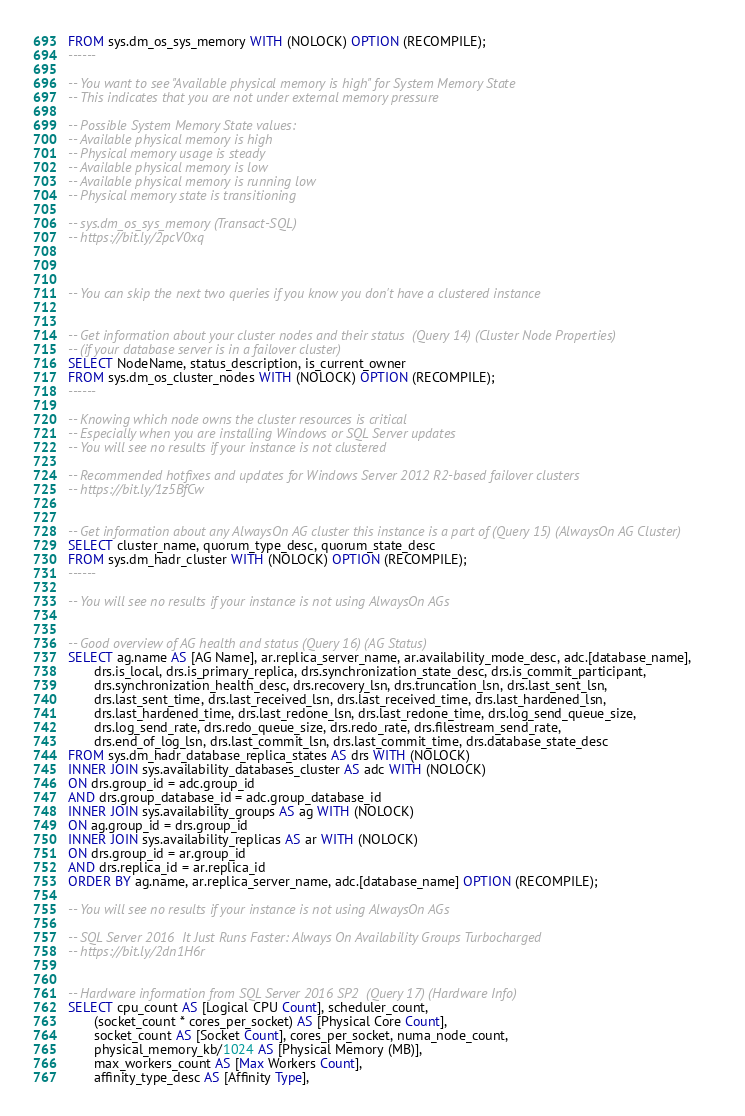<code> <loc_0><loc_0><loc_500><loc_500><_SQL_>FROM sys.dm_os_sys_memory WITH (NOLOCK) OPTION (RECOMPILE);
------

-- You want to see "Available physical memory is high" for System Memory State
-- This indicates that you are not under external memory pressure

-- Possible System Memory State values:
-- Available physical memory is high
-- Physical memory usage is steady
-- Available physical memory is low
-- Available physical memory is running low
-- Physical memory state is transitioning

-- sys.dm_os_sys_memory (Transact-SQL)
-- https://bit.ly/2pcV0xq



-- You can skip the next two queries if you know you don't have a clustered instance


-- Get information about your cluster nodes and their status  (Query 14) (Cluster Node Properties)
-- (if your database server is in a failover cluster)
SELECT NodeName, status_description, is_current_owner
FROM sys.dm_os_cluster_nodes WITH (NOLOCK) OPTION (RECOMPILE);
------

-- Knowing which node owns the cluster resources is critical
-- Especially when you are installing Windows or SQL Server updates
-- You will see no results if your instance is not clustered

-- Recommended hotfixes and updates for Windows Server 2012 R2-based failover clusters
-- https://bit.ly/1z5BfCw


-- Get information about any AlwaysOn AG cluster this instance is a part of (Query 15) (AlwaysOn AG Cluster)
SELECT cluster_name, quorum_type_desc, quorum_state_desc
FROM sys.dm_hadr_cluster WITH (NOLOCK) OPTION (RECOMPILE);
------

-- You will see no results if your instance is not using AlwaysOn AGs


-- Good overview of AG health and status (Query 16) (AG Status)
SELECT ag.name AS [AG Name], ar.replica_server_name, ar.availability_mode_desc, adc.[database_name], 
       drs.is_local, drs.is_primary_replica, drs.synchronization_state_desc, drs.is_commit_participant, 
	   drs.synchronization_health_desc, drs.recovery_lsn, drs.truncation_lsn, drs.last_sent_lsn, 
	   drs.last_sent_time, drs.last_received_lsn, drs.last_received_time, drs.last_hardened_lsn, 
	   drs.last_hardened_time, drs.last_redone_lsn, drs.last_redone_time, drs.log_send_queue_size, 
	   drs.log_send_rate, drs.redo_queue_size, drs.redo_rate, drs.filestream_send_rate, 
	   drs.end_of_log_lsn, drs.last_commit_lsn, drs.last_commit_time, drs.database_state_desc 
FROM sys.dm_hadr_database_replica_states AS drs WITH (NOLOCK)
INNER JOIN sys.availability_databases_cluster AS adc WITH (NOLOCK)
ON drs.group_id = adc.group_id 
AND drs.group_database_id = adc.group_database_id
INNER JOIN sys.availability_groups AS ag WITH (NOLOCK)
ON ag.group_id = drs.group_id
INNER JOIN sys.availability_replicas AS ar WITH (NOLOCK)
ON drs.group_id = ar.group_id 
AND drs.replica_id = ar.replica_id
ORDER BY ag.name, ar.replica_server_name, adc.[database_name] OPTION (RECOMPILE);

-- You will see no results if your instance is not using AlwaysOn AGs

-- SQL Server 2016  It Just Runs Faster: Always On Availability Groups Turbocharged
-- https://bit.ly/2dn1H6r


-- Hardware information from SQL Server 2016 SP2  (Query 17) (Hardware Info)
SELECT cpu_count AS [Logical CPU Count], scheduler_count, 
       (socket_count * cores_per_socket) AS [Physical Core Count], 
       socket_count AS [Socket Count], cores_per_socket, numa_node_count,
       physical_memory_kb/1024 AS [Physical Memory (MB)], 
       max_workers_count AS [Max Workers Count], 
	   affinity_type_desc AS [Affinity Type], </code> 